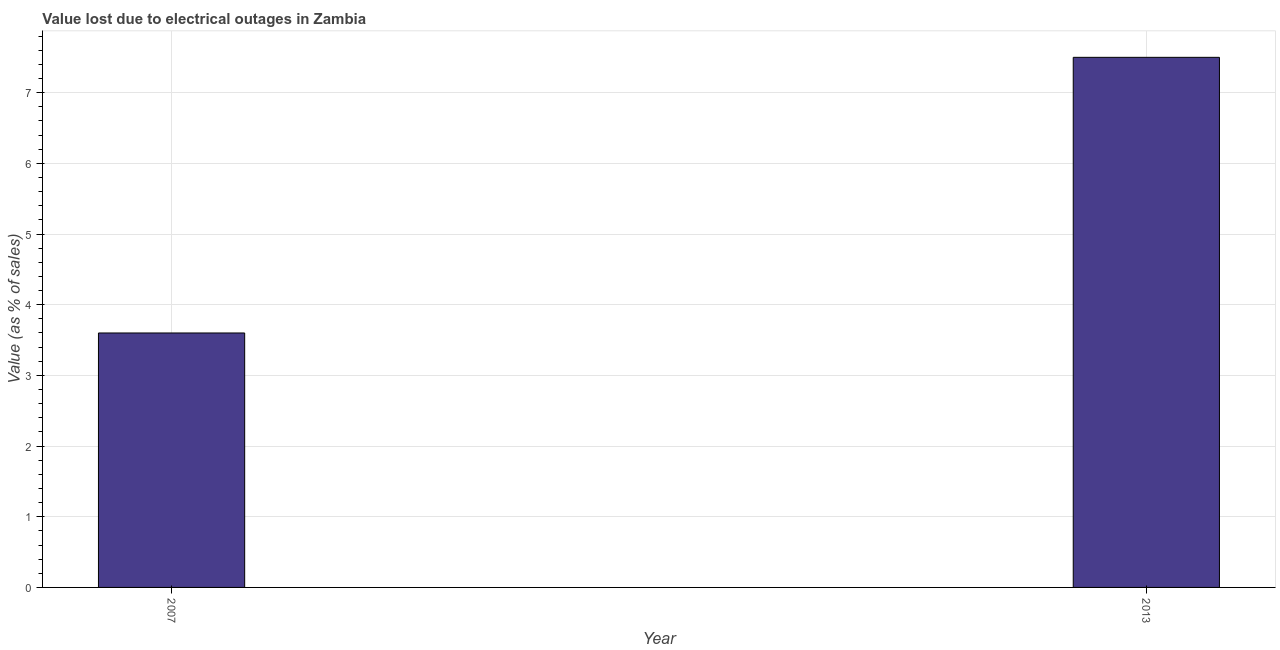Does the graph contain any zero values?
Give a very brief answer. No. What is the title of the graph?
Keep it short and to the point. Value lost due to electrical outages in Zambia. What is the label or title of the X-axis?
Your answer should be compact. Year. What is the label or title of the Y-axis?
Your response must be concise. Value (as % of sales). What is the value lost due to electrical outages in 2007?
Offer a terse response. 3.6. Across all years, what is the minimum value lost due to electrical outages?
Offer a terse response. 3.6. In which year was the value lost due to electrical outages minimum?
Your response must be concise. 2007. What is the average value lost due to electrical outages per year?
Give a very brief answer. 5.55. What is the median value lost due to electrical outages?
Your answer should be very brief. 5.55. In how many years, is the value lost due to electrical outages greater than 5.6 %?
Offer a very short reply. 1. Do a majority of the years between 2007 and 2013 (inclusive) have value lost due to electrical outages greater than 3.4 %?
Offer a very short reply. Yes. What is the ratio of the value lost due to electrical outages in 2007 to that in 2013?
Your answer should be very brief. 0.48. In how many years, is the value lost due to electrical outages greater than the average value lost due to electrical outages taken over all years?
Make the answer very short. 1. How many bars are there?
Give a very brief answer. 2. What is the difference between two consecutive major ticks on the Y-axis?
Your answer should be compact. 1. Are the values on the major ticks of Y-axis written in scientific E-notation?
Ensure brevity in your answer.  No. What is the Value (as % of sales) of 2007?
Provide a succinct answer. 3.6. What is the Value (as % of sales) of 2013?
Your answer should be very brief. 7.5. What is the ratio of the Value (as % of sales) in 2007 to that in 2013?
Provide a succinct answer. 0.48. 